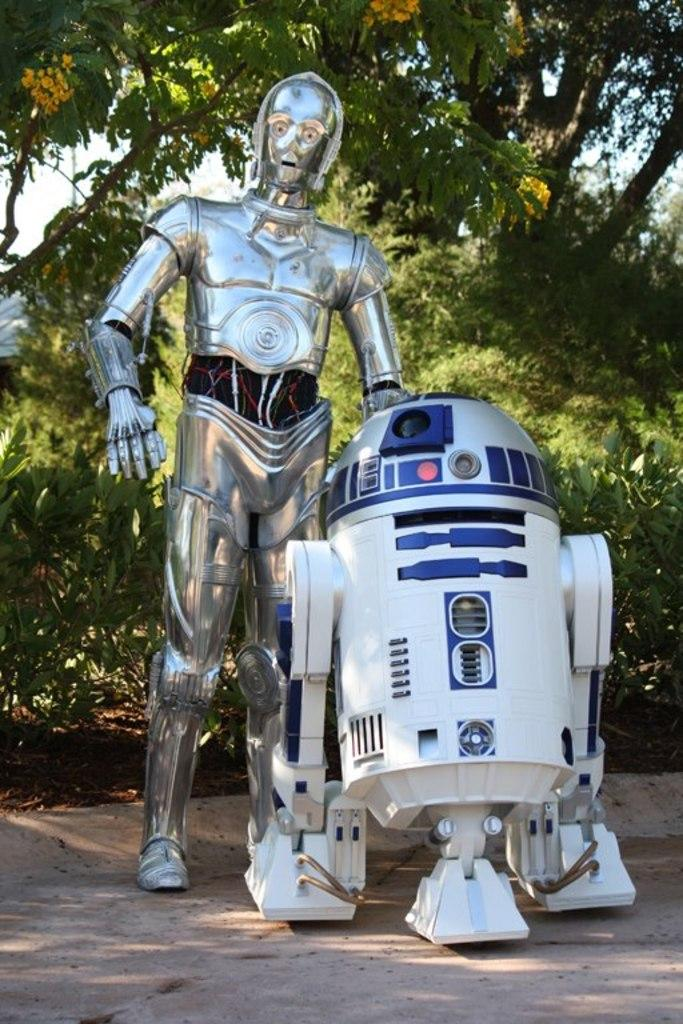What is the main subject in the image? There is a robot in the image. What is the robot holding in its hand? The robot is holding an electrical equipment. What can be seen in the background of the image? There are trees visible in the background of the image. What type of bells can be heard ringing in the image? There are no bells present in the image, and therefore no sound can be heard. 